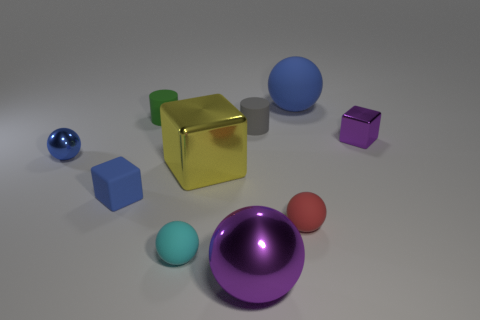Subtract all tiny purple cubes. How many cubes are left? 2 Subtract all yellow blocks. How many blocks are left? 2 Subtract 3 spheres. How many spheres are left? 2 Subtract all cylinders. How many objects are left? 8 Add 5 gray rubber cylinders. How many gray rubber cylinders exist? 6 Subtract 0 green spheres. How many objects are left? 10 Subtract all cyan cylinders. Subtract all red cubes. How many cylinders are left? 2 Subtract all yellow cylinders. How many red balls are left? 1 Subtract all yellow shiny cubes. Subtract all small green matte objects. How many objects are left? 8 Add 1 gray rubber cylinders. How many gray rubber cylinders are left? 2 